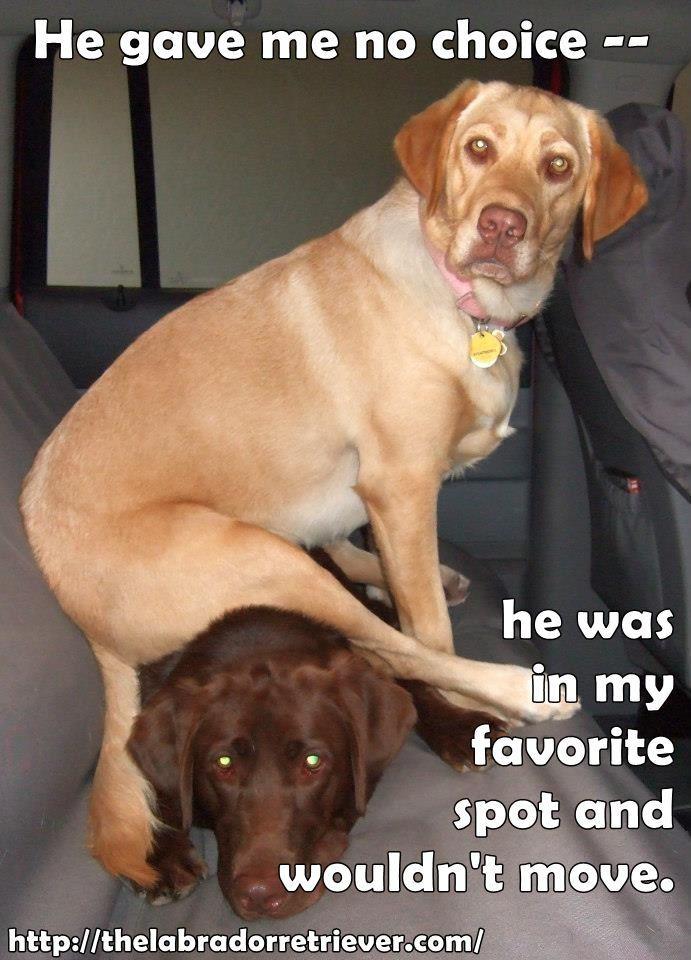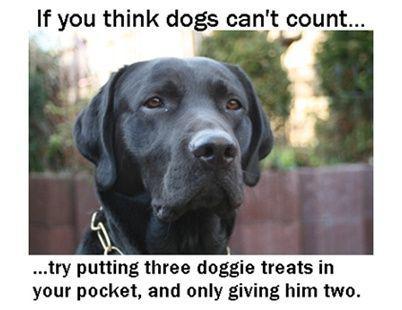The first image is the image on the left, the second image is the image on the right. Examine the images to the left and right. Is the description "There are two dogs in the image on the left." accurate? Answer yes or no. Yes. 